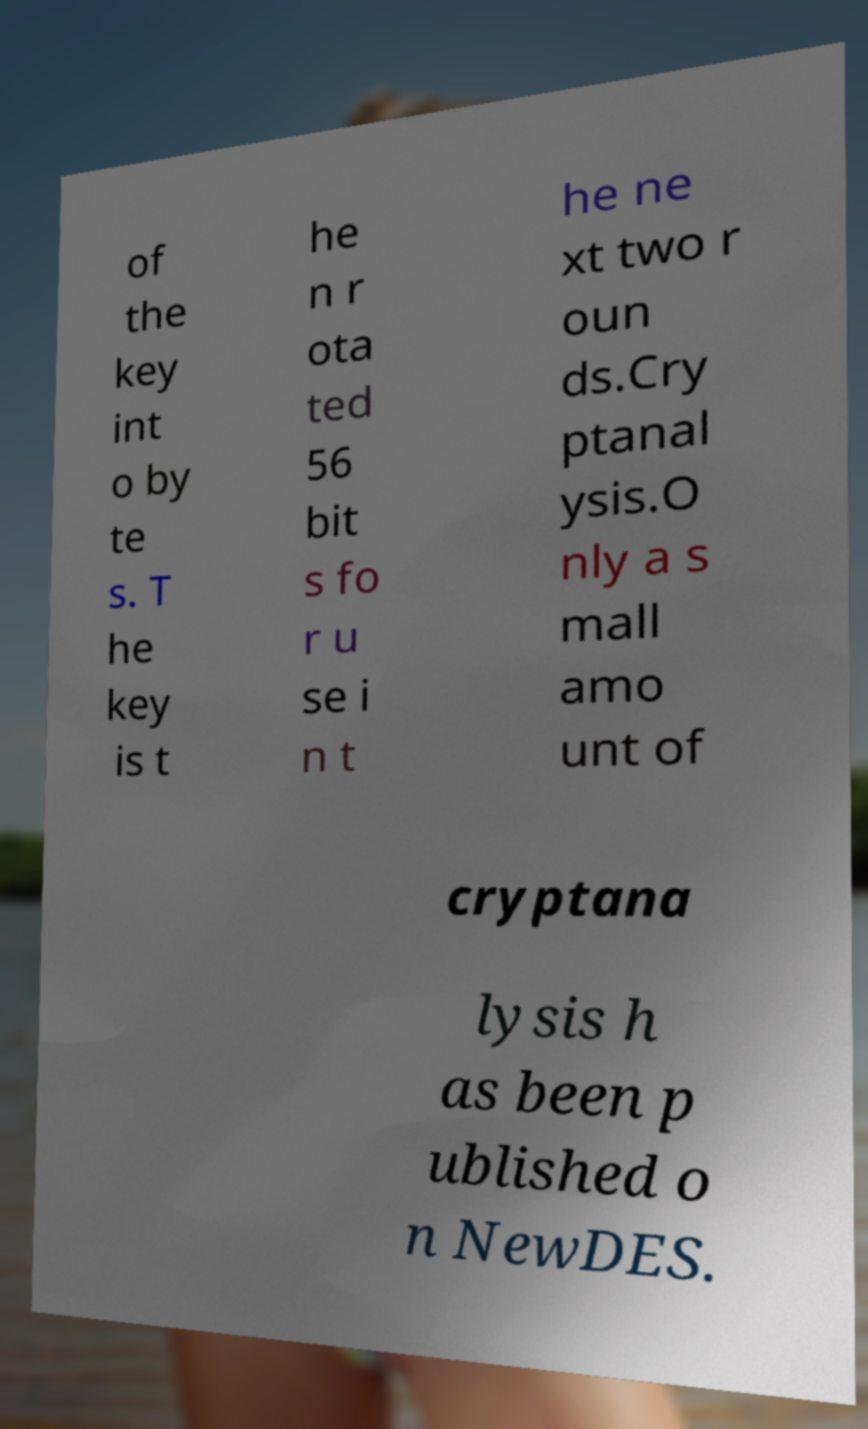I need the written content from this picture converted into text. Can you do that? of the key int o by te s. T he key is t he n r ota ted 56 bit s fo r u se i n t he ne xt two r oun ds.Cry ptanal ysis.O nly a s mall amo unt of cryptana lysis h as been p ublished o n NewDES. 